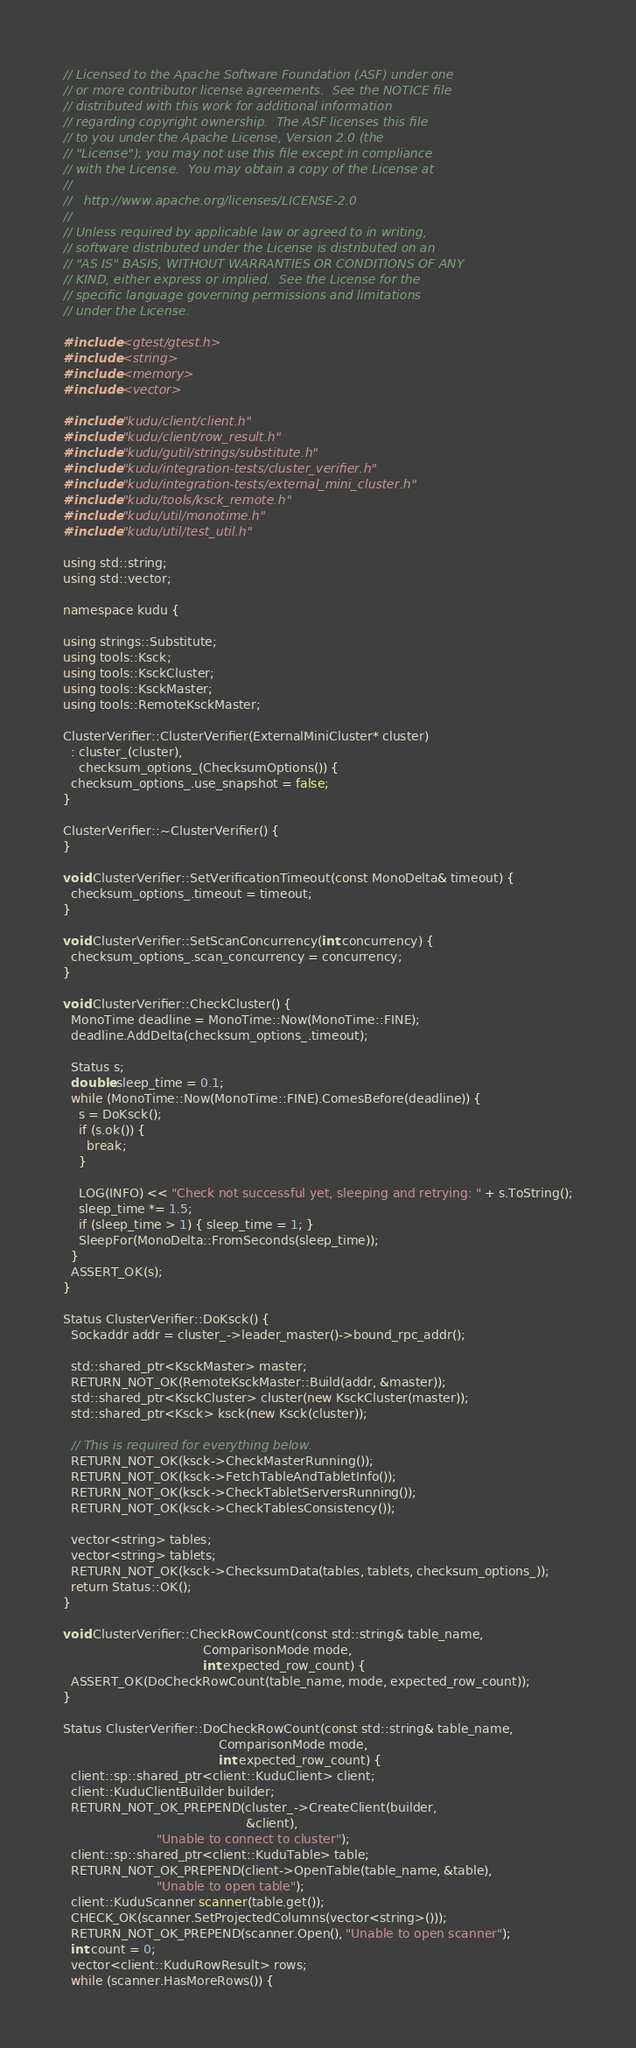Convert code to text. <code><loc_0><loc_0><loc_500><loc_500><_C++_>// Licensed to the Apache Software Foundation (ASF) under one
// or more contributor license agreements.  See the NOTICE file
// distributed with this work for additional information
// regarding copyright ownership.  The ASF licenses this file
// to you under the Apache License, Version 2.0 (the
// "License"); you may not use this file except in compliance
// with the License.  You may obtain a copy of the License at
//
//   http://www.apache.org/licenses/LICENSE-2.0
//
// Unless required by applicable law or agreed to in writing,
// software distributed under the License is distributed on an
// "AS IS" BASIS, WITHOUT WARRANTIES OR CONDITIONS OF ANY
// KIND, either express or implied.  See the License for the
// specific language governing permissions and limitations
// under the License.

#include <gtest/gtest.h>
#include <string>
#include <memory>
#include <vector>

#include "kudu/client/client.h"
#include "kudu/client/row_result.h"
#include "kudu/gutil/strings/substitute.h"
#include "kudu/integration-tests/cluster_verifier.h"
#include "kudu/integration-tests/external_mini_cluster.h"
#include "kudu/tools/ksck_remote.h"
#include "kudu/util/monotime.h"
#include "kudu/util/test_util.h"

using std::string;
using std::vector;

namespace kudu {

using strings::Substitute;
using tools::Ksck;
using tools::KsckCluster;
using tools::KsckMaster;
using tools::RemoteKsckMaster;

ClusterVerifier::ClusterVerifier(ExternalMiniCluster* cluster)
  : cluster_(cluster),
    checksum_options_(ChecksumOptions()) {
  checksum_options_.use_snapshot = false;
}

ClusterVerifier::~ClusterVerifier() {
}

void ClusterVerifier::SetVerificationTimeout(const MonoDelta& timeout) {
  checksum_options_.timeout = timeout;
}

void ClusterVerifier::SetScanConcurrency(int concurrency) {
  checksum_options_.scan_concurrency = concurrency;
}

void ClusterVerifier::CheckCluster() {
  MonoTime deadline = MonoTime::Now(MonoTime::FINE);
  deadline.AddDelta(checksum_options_.timeout);

  Status s;
  double sleep_time = 0.1;
  while (MonoTime::Now(MonoTime::FINE).ComesBefore(deadline)) {
    s = DoKsck();
    if (s.ok()) {
      break;
    }

    LOG(INFO) << "Check not successful yet, sleeping and retrying: " + s.ToString();
    sleep_time *= 1.5;
    if (sleep_time > 1) { sleep_time = 1; }
    SleepFor(MonoDelta::FromSeconds(sleep_time));
  }
  ASSERT_OK(s);
}

Status ClusterVerifier::DoKsck() {
  Sockaddr addr = cluster_->leader_master()->bound_rpc_addr();

  std::shared_ptr<KsckMaster> master;
  RETURN_NOT_OK(RemoteKsckMaster::Build(addr, &master));
  std::shared_ptr<KsckCluster> cluster(new KsckCluster(master));
  std::shared_ptr<Ksck> ksck(new Ksck(cluster));

  // This is required for everything below.
  RETURN_NOT_OK(ksck->CheckMasterRunning());
  RETURN_NOT_OK(ksck->FetchTableAndTabletInfo());
  RETURN_NOT_OK(ksck->CheckTabletServersRunning());
  RETURN_NOT_OK(ksck->CheckTablesConsistency());

  vector<string> tables;
  vector<string> tablets;
  RETURN_NOT_OK(ksck->ChecksumData(tables, tablets, checksum_options_));
  return Status::OK();
}

void ClusterVerifier::CheckRowCount(const std::string& table_name,
                                    ComparisonMode mode,
                                    int expected_row_count) {
  ASSERT_OK(DoCheckRowCount(table_name, mode, expected_row_count));
}

Status ClusterVerifier::DoCheckRowCount(const std::string& table_name,
                                        ComparisonMode mode,
                                        int expected_row_count) {
  client::sp::shared_ptr<client::KuduClient> client;
  client::KuduClientBuilder builder;
  RETURN_NOT_OK_PREPEND(cluster_->CreateClient(builder,
                                               &client),
                        "Unable to connect to cluster");
  client::sp::shared_ptr<client::KuduTable> table;
  RETURN_NOT_OK_PREPEND(client->OpenTable(table_name, &table),
                        "Unable to open table");
  client::KuduScanner scanner(table.get());
  CHECK_OK(scanner.SetProjectedColumns(vector<string>()));
  RETURN_NOT_OK_PREPEND(scanner.Open(), "Unable to open scanner");
  int count = 0;
  vector<client::KuduRowResult> rows;
  while (scanner.HasMoreRows()) {</code> 